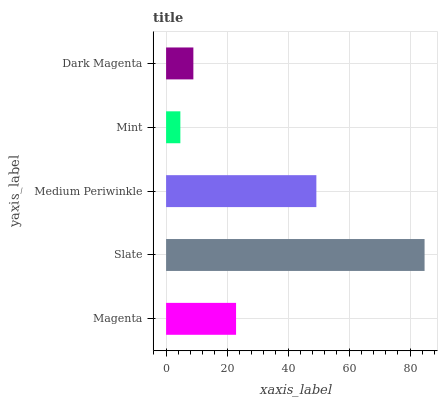Is Mint the minimum?
Answer yes or no. Yes. Is Slate the maximum?
Answer yes or no. Yes. Is Medium Periwinkle the minimum?
Answer yes or no. No. Is Medium Periwinkle the maximum?
Answer yes or no. No. Is Slate greater than Medium Periwinkle?
Answer yes or no. Yes. Is Medium Periwinkle less than Slate?
Answer yes or no. Yes. Is Medium Periwinkle greater than Slate?
Answer yes or no. No. Is Slate less than Medium Periwinkle?
Answer yes or no. No. Is Magenta the high median?
Answer yes or no. Yes. Is Magenta the low median?
Answer yes or no. Yes. Is Dark Magenta the high median?
Answer yes or no. No. Is Medium Periwinkle the low median?
Answer yes or no. No. 